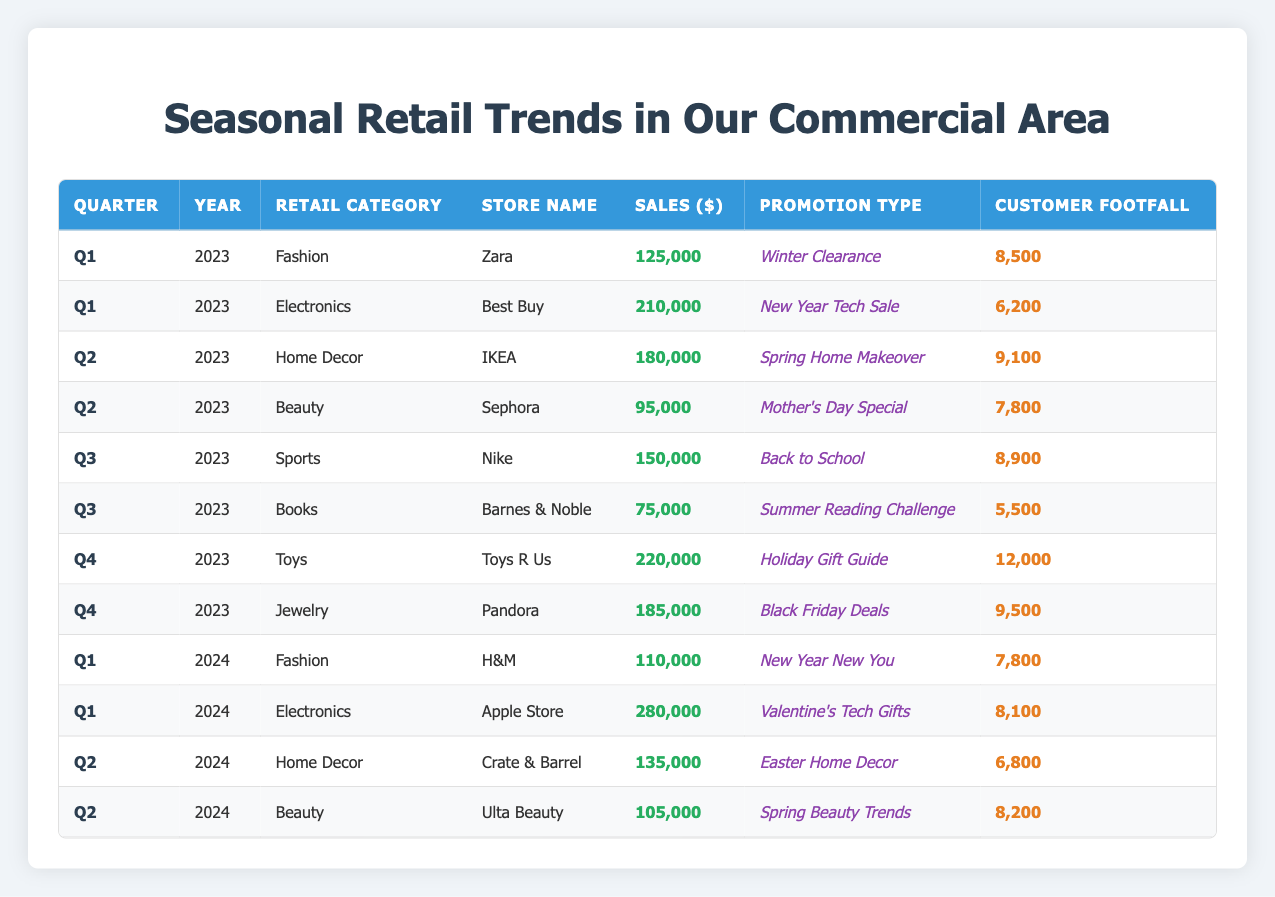What is the total sales for the Fashion category across all quarters in 2023? To find the total sales for the Fashion category in 2023, we look for the sales figures in the rows for that category and year. From the table, Zara in Q1 2023 had sales of 125,000. Since there are no other Fashion entries in 2023, the total sales is simply 125,000.
Answer: 125000 Which store had the highest customer footfall in Q4 2023? In Q4 2023, the table shows Toys R Us with a footfall of 12,000 and Pandora with 9,500. Comparing these numbers, Toys R Us has the highest customer footfall in Q4 2023.
Answer: Toys R Us Is the promotion type "Easter Home Decor" associated with a retail category in Q2 2024? Yes, the promotion type "Easter Home Decor" is associated with the Home Decor retail category in Q2 2024 as indicated in the table.
Answer: Yes What is the difference in sales between the highest and lowest sales in Q2 2023? In Q2 2023, IKEA in Home Decor had sales of 180,000, while Sephora in Beauty had sales of 95,000. The difference is calculated as 180,000 - 95,000 = 85,000.
Answer: 85000 What is the average customer footfall for the Electronics category across all quarters? The customer footfall for Electronics is recorded as 6,200 (Best Buy in Q1 2023) and 8,100 (Apple Store in Q1 2024). To find the average, we sum the footfall values (6,200 + 8,100 = 14,300) and then divide by the number of entries (2). Thus, the average is 14,300 / 2 = 7,150.
Answer: 7150 In Q3 2023, did the total sales for Sports exceed the total sales for Books? The total sales for Sports (Nike) is 150,000 in Q3 2023, while the total sales for Books (Barnes & Noble) is 75,000. Since 150,000 is greater than 75,000, the statement is true.
Answer: Yes What was the promotion type associated with the highest sales in Q4 2023? In Q4 2023, Toys R Us had the highest sales at 220,000, and the associated promotion type is "Holiday Gift Guide." Therefore, "Holiday Gift Guide" is the promotion type for the highest sales.
Answer: Holiday Gift Guide Calculate the total sales for Home Decor across all quarters. In the data, IKEA in Q2 2023 had sales of 180,000 and Crate & Barrel in Q2 2024 had sales of 135,000. Adding these sales gives 180,000 + 135,000 = 315,000 as the total sales for Home Decor across all quarters.
Answer: 315000 